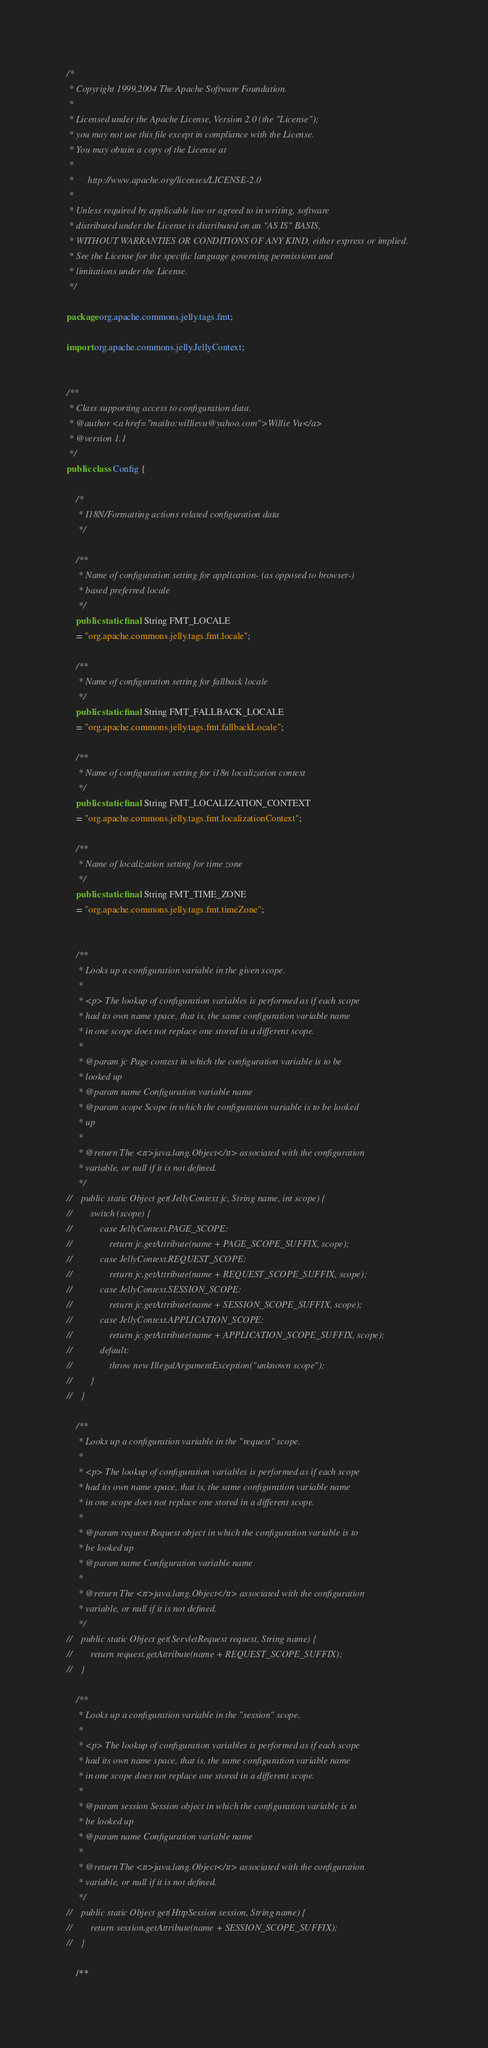Convert code to text. <code><loc_0><loc_0><loc_500><loc_500><_Java_>/*
 * Copyright 1999,2004 The Apache Software Foundation.
 *
 * Licensed under the Apache License, Version 2.0 (the "License");
 * you may not use this file except in compliance with the License.
 * You may obtain a copy of the License at
 *
 *      http://www.apache.org/licenses/LICENSE-2.0
 *
 * Unless required by applicable law or agreed to in writing, software
 * distributed under the License is distributed on an "AS IS" BASIS,
 * WITHOUT WARRANTIES OR CONDITIONS OF ANY KIND, either express or implied.
 * See the License for the specific language governing permissions and
 * limitations under the License.
 */

package org.apache.commons.jelly.tags.fmt;

import org.apache.commons.jelly.JellyContext;


/**
 * Class supporting access to configuration data.
 * @author <a href="mailto:willievu@yahoo.com">Willie Vu</a>
 * @version 1.1
 */
public class Config {

    /*
     * I18N/Formatting actions related configuration data
     */

    /**
     * Name of configuration setting for application- (as opposed to browser-)
     * based preferred locale
     */
    public static final String FMT_LOCALE
    = "org.apache.commons.jelly.tags.fmt.locale";

    /**
     * Name of configuration setting for fallback locale
     */
    public static final String FMT_FALLBACK_LOCALE
    = "org.apache.commons.jelly.tags.fmt.fallbackLocale";

    /**
     * Name of configuration setting for i18n localization context
     */
    public static final String FMT_LOCALIZATION_CONTEXT
    = "org.apache.commons.jelly.tags.fmt.localizationContext";

    /**
     * Name of localization setting for time zone
     */
    public static final String FMT_TIME_ZONE
    = "org.apache.commons.jelly.tags.fmt.timeZone";


    /**
     * Looks up a configuration variable in the given scope.
     *
     * <p> The lookup of configuration variables is performed as if each scope
     * had its own name space, that is, the same configuration variable name
     * in one scope does not replace one stored in a different scope.
     *
     * @param jc Page context in which the configuration variable is to be
     * looked up
     * @param name Configuration variable name
     * @param scope Scope in which the configuration variable is to be looked
     * up
     *
     * @return The <tt>java.lang.Object</tt> associated with the configuration
     * variable, or null if it is not defined.
     */
//    public static Object get(JellyContext jc, String name, int scope) {
//        switch (scope) {
//            case JellyContext.PAGE_SCOPE:
//                return jc.getAttribute(name + PAGE_SCOPE_SUFFIX, scope);
//            case JellyContext.REQUEST_SCOPE:
//                return jc.getAttribute(name + REQUEST_SCOPE_SUFFIX, scope);
//            case JellyContext.SESSION_SCOPE:
//                return jc.getAttribute(name + SESSION_SCOPE_SUFFIX, scope);
//            case JellyContext.APPLICATION_SCOPE:
//                return jc.getAttribute(name + APPLICATION_SCOPE_SUFFIX, scope);
//            default:
//                throw new IllegalArgumentException("unknown scope");
//        }
//    }

    /**
     * Looks up a configuration variable in the "request" scope.
     *
     * <p> The lookup of configuration variables is performed as if each scope
     * had its own name space, that is, the same configuration variable name
     * in one scope does not replace one stored in a different scope.
     *
     * @param request Request object in which the configuration variable is to
     * be looked up
     * @param name Configuration variable name
     *
     * @return The <tt>java.lang.Object</tt> associated with the configuration
     * variable, or null if it is not defined.
     */
//    public static Object get(ServletRequest request, String name) {
//        return request.getAttribute(name + REQUEST_SCOPE_SUFFIX);
//    }

    /**
     * Looks up a configuration variable in the "session" scope.
     *
     * <p> The lookup of configuration variables is performed as if each scope
     * had its own name space, that is, the same configuration variable name
     * in one scope does not replace one stored in a different scope.
     *
     * @param session Session object in which the configuration variable is to
     * be looked up
     * @param name Configuration variable name
     *
     * @return The <tt>java.lang.Object</tt> associated with the configuration
     * variable, or null if it is not defined.
     */
//    public static Object get(HttpSession session, String name) {
//        return session.getAttribute(name + SESSION_SCOPE_SUFFIX);
//    }

    /**</code> 